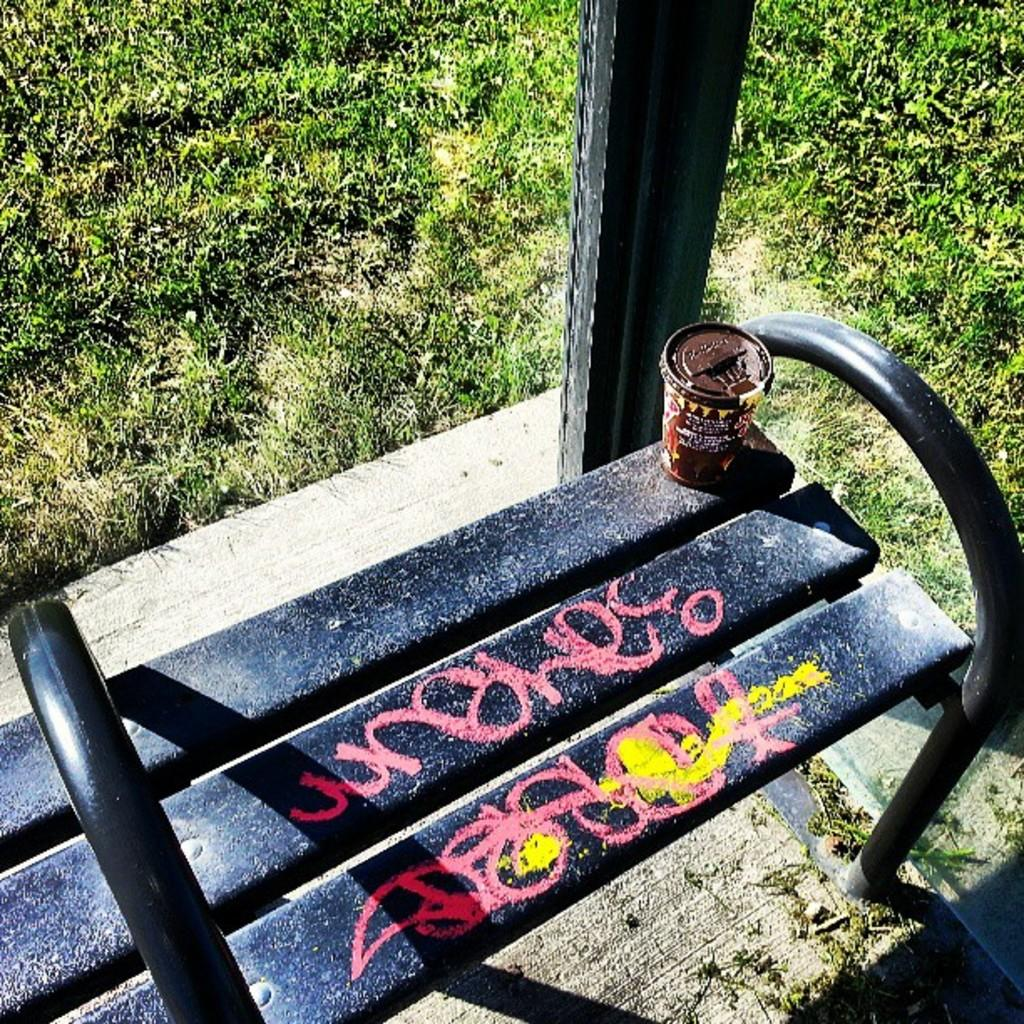What type of vegetation is visible in the image? There is grass in the image. What type of seating is present in the image? There is a black-colored bench in the image. What object is placed on the bench? There is a brown-colored glass on the bench. What type of artwork is visible in the image? There is a pink-colored painting in the image. How many cows are grazing in the grass in the image? There are no cows present in the image; it only features grass. What type of shirt is the judge wearing in the image? There is no judge present in the image, so it is not possible to determine the type of shirt they might be wearing. 